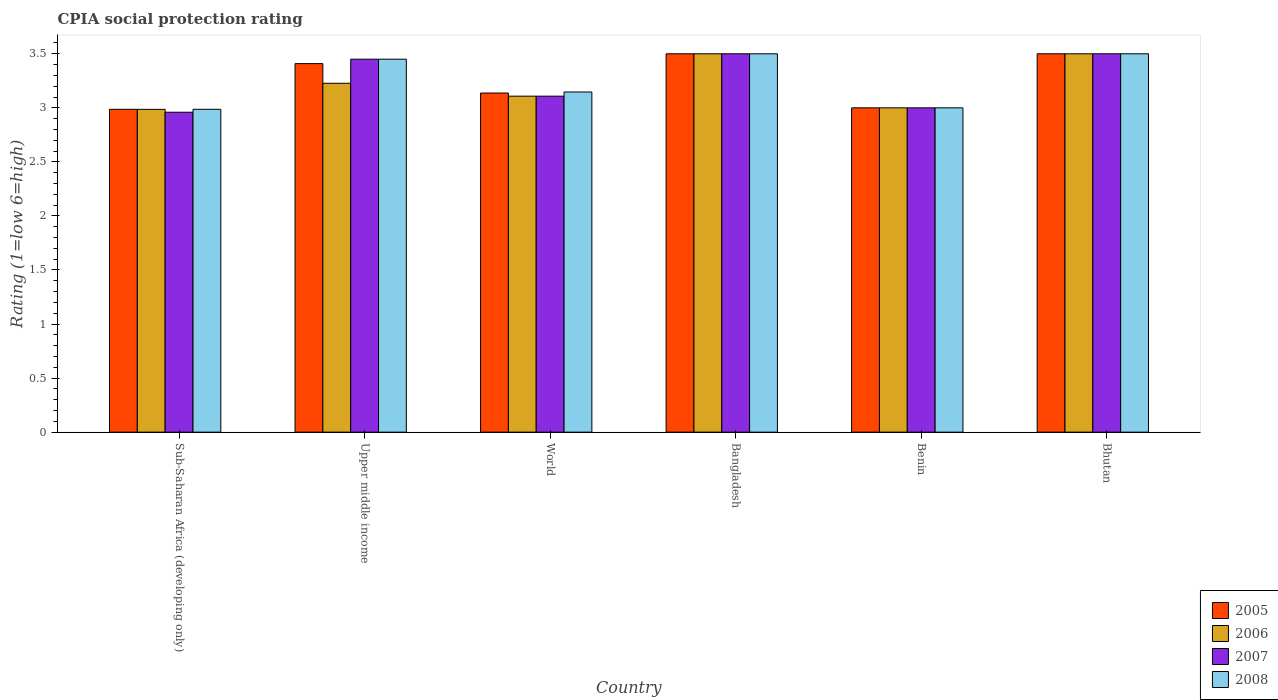Are the number of bars per tick equal to the number of legend labels?
Your answer should be very brief. Yes. Are the number of bars on each tick of the X-axis equal?
Ensure brevity in your answer.  Yes. How many bars are there on the 3rd tick from the right?
Ensure brevity in your answer.  4. What is the label of the 5th group of bars from the left?
Your response must be concise. Benin. In how many cases, is the number of bars for a given country not equal to the number of legend labels?
Your answer should be very brief. 0. What is the CPIA rating in 2008 in Bhutan?
Your answer should be compact. 3.5. Across all countries, what is the minimum CPIA rating in 2005?
Provide a succinct answer. 2.99. In which country was the CPIA rating in 2006 maximum?
Your response must be concise. Bangladesh. In which country was the CPIA rating in 2005 minimum?
Make the answer very short. Sub-Saharan Africa (developing only). What is the total CPIA rating in 2007 in the graph?
Keep it short and to the point. 19.52. What is the difference between the CPIA rating in 2007 in Benin and that in Sub-Saharan Africa (developing only)?
Provide a succinct answer. 0.04. What is the difference between the CPIA rating in 2005 in Bhutan and the CPIA rating in 2006 in Upper middle income?
Make the answer very short. 0.27. What is the average CPIA rating in 2006 per country?
Your response must be concise. 3.22. What is the difference between the CPIA rating of/in 2007 and CPIA rating of/in 2008 in Sub-Saharan Africa (developing only)?
Keep it short and to the point. -0.03. What is the ratio of the CPIA rating in 2006 in Bhutan to that in Upper middle income?
Your response must be concise. 1.08. Is the CPIA rating in 2005 in Bangladesh less than that in World?
Ensure brevity in your answer.  No. Is the difference between the CPIA rating in 2007 in Bangladesh and Sub-Saharan Africa (developing only) greater than the difference between the CPIA rating in 2008 in Bangladesh and Sub-Saharan Africa (developing only)?
Keep it short and to the point. Yes. What is the difference between the highest and the second highest CPIA rating in 2007?
Offer a terse response. -0.05. What is the difference between the highest and the lowest CPIA rating in 2007?
Provide a succinct answer. 0.54. In how many countries, is the CPIA rating in 2005 greater than the average CPIA rating in 2005 taken over all countries?
Offer a terse response. 3. Is the sum of the CPIA rating in 2006 in Bangladesh and Benin greater than the maximum CPIA rating in 2007 across all countries?
Make the answer very short. Yes. What does the 3rd bar from the left in World represents?
Your answer should be very brief. 2007. Is it the case that in every country, the sum of the CPIA rating in 2008 and CPIA rating in 2005 is greater than the CPIA rating in 2006?
Make the answer very short. Yes. What is the difference between two consecutive major ticks on the Y-axis?
Offer a very short reply. 0.5. Are the values on the major ticks of Y-axis written in scientific E-notation?
Make the answer very short. No. Where does the legend appear in the graph?
Offer a terse response. Bottom right. What is the title of the graph?
Make the answer very short. CPIA social protection rating. Does "2001" appear as one of the legend labels in the graph?
Your answer should be very brief. No. What is the label or title of the Y-axis?
Provide a short and direct response. Rating (1=low 6=high). What is the Rating (1=low 6=high) of 2005 in Sub-Saharan Africa (developing only)?
Give a very brief answer. 2.99. What is the Rating (1=low 6=high) of 2006 in Sub-Saharan Africa (developing only)?
Your answer should be compact. 2.99. What is the Rating (1=low 6=high) of 2007 in Sub-Saharan Africa (developing only)?
Your response must be concise. 2.96. What is the Rating (1=low 6=high) in 2008 in Sub-Saharan Africa (developing only)?
Give a very brief answer. 2.99. What is the Rating (1=low 6=high) of 2005 in Upper middle income?
Offer a very short reply. 3.41. What is the Rating (1=low 6=high) in 2006 in Upper middle income?
Your answer should be very brief. 3.23. What is the Rating (1=low 6=high) of 2007 in Upper middle income?
Keep it short and to the point. 3.45. What is the Rating (1=low 6=high) in 2008 in Upper middle income?
Your answer should be very brief. 3.45. What is the Rating (1=low 6=high) in 2005 in World?
Provide a succinct answer. 3.14. What is the Rating (1=low 6=high) in 2006 in World?
Your answer should be compact. 3.11. What is the Rating (1=low 6=high) of 2007 in World?
Keep it short and to the point. 3.11. What is the Rating (1=low 6=high) of 2008 in World?
Keep it short and to the point. 3.15. What is the Rating (1=low 6=high) of 2007 in Bangladesh?
Make the answer very short. 3.5. What is the Rating (1=low 6=high) of 2008 in Bangladesh?
Your answer should be very brief. 3.5. What is the Rating (1=low 6=high) of 2008 in Benin?
Your answer should be very brief. 3. What is the Rating (1=low 6=high) in 2006 in Bhutan?
Offer a very short reply. 3.5. What is the Rating (1=low 6=high) of 2008 in Bhutan?
Ensure brevity in your answer.  3.5. Across all countries, what is the maximum Rating (1=low 6=high) of 2005?
Your response must be concise. 3.5. Across all countries, what is the maximum Rating (1=low 6=high) of 2008?
Ensure brevity in your answer.  3.5. Across all countries, what is the minimum Rating (1=low 6=high) of 2005?
Keep it short and to the point. 2.99. Across all countries, what is the minimum Rating (1=low 6=high) of 2006?
Give a very brief answer. 2.99. Across all countries, what is the minimum Rating (1=low 6=high) in 2007?
Make the answer very short. 2.96. Across all countries, what is the minimum Rating (1=low 6=high) in 2008?
Provide a succinct answer. 2.99. What is the total Rating (1=low 6=high) in 2005 in the graph?
Offer a very short reply. 19.53. What is the total Rating (1=low 6=high) of 2006 in the graph?
Keep it short and to the point. 19.32. What is the total Rating (1=low 6=high) of 2007 in the graph?
Offer a terse response. 19.52. What is the total Rating (1=low 6=high) of 2008 in the graph?
Ensure brevity in your answer.  19.58. What is the difference between the Rating (1=low 6=high) in 2005 in Sub-Saharan Africa (developing only) and that in Upper middle income?
Provide a succinct answer. -0.42. What is the difference between the Rating (1=low 6=high) of 2006 in Sub-Saharan Africa (developing only) and that in Upper middle income?
Your response must be concise. -0.24. What is the difference between the Rating (1=low 6=high) of 2007 in Sub-Saharan Africa (developing only) and that in Upper middle income?
Your response must be concise. -0.49. What is the difference between the Rating (1=low 6=high) in 2008 in Sub-Saharan Africa (developing only) and that in Upper middle income?
Offer a very short reply. -0.46. What is the difference between the Rating (1=low 6=high) in 2005 in Sub-Saharan Africa (developing only) and that in World?
Give a very brief answer. -0.15. What is the difference between the Rating (1=low 6=high) in 2006 in Sub-Saharan Africa (developing only) and that in World?
Ensure brevity in your answer.  -0.12. What is the difference between the Rating (1=low 6=high) in 2007 in Sub-Saharan Africa (developing only) and that in World?
Provide a succinct answer. -0.15. What is the difference between the Rating (1=low 6=high) in 2008 in Sub-Saharan Africa (developing only) and that in World?
Make the answer very short. -0.16. What is the difference between the Rating (1=low 6=high) of 2005 in Sub-Saharan Africa (developing only) and that in Bangladesh?
Make the answer very short. -0.51. What is the difference between the Rating (1=low 6=high) in 2006 in Sub-Saharan Africa (developing only) and that in Bangladesh?
Offer a terse response. -0.51. What is the difference between the Rating (1=low 6=high) in 2007 in Sub-Saharan Africa (developing only) and that in Bangladesh?
Offer a very short reply. -0.54. What is the difference between the Rating (1=low 6=high) in 2008 in Sub-Saharan Africa (developing only) and that in Bangladesh?
Your response must be concise. -0.51. What is the difference between the Rating (1=low 6=high) of 2005 in Sub-Saharan Africa (developing only) and that in Benin?
Offer a very short reply. -0.01. What is the difference between the Rating (1=low 6=high) in 2006 in Sub-Saharan Africa (developing only) and that in Benin?
Make the answer very short. -0.01. What is the difference between the Rating (1=low 6=high) in 2007 in Sub-Saharan Africa (developing only) and that in Benin?
Provide a succinct answer. -0.04. What is the difference between the Rating (1=low 6=high) in 2008 in Sub-Saharan Africa (developing only) and that in Benin?
Offer a very short reply. -0.01. What is the difference between the Rating (1=low 6=high) in 2005 in Sub-Saharan Africa (developing only) and that in Bhutan?
Your response must be concise. -0.51. What is the difference between the Rating (1=low 6=high) in 2006 in Sub-Saharan Africa (developing only) and that in Bhutan?
Keep it short and to the point. -0.51. What is the difference between the Rating (1=low 6=high) of 2007 in Sub-Saharan Africa (developing only) and that in Bhutan?
Provide a succinct answer. -0.54. What is the difference between the Rating (1=low 6=high) of 2008 in Sub-Saharan Africa (developing only) and that in Bhutan?
Ensure brevity in your answer.  -0.51. What is the difference between the Rating (1=low 6=high) of 2005 in Upper middle income and that in World?
Keep it short and to the point. 0.27. What is the difference between the Rating (1=low 6=high) in 2006 in Upper middle income and that in World?
Provide a short and direct response. 0.12. What is the difference between the Rating (1=low 6=high) of 2007 in Upper middle income and that in World?
Provide a short and direct response. 0.34. What is the difference between the Rating (1=low 6=high) in 2008 in Upper middle income and that in World?
Your answer should be compact. 0.3. What is the difference between the Rating (1=low 6=high) in 2005 in Upper middle income and that in Bangladesh?
Give a very brief answer. -0.09. What is the difference between the Rating (1=low 6=high) of 2006 in Upper middle income and that in Bangladesh?
Your answer should be very brief. -0.27. What is the difference between the Rating (1=low 6=high) in 2007 in Upper middle income and that in Bangladesh?
Offer a very short reply. -0.05. What is the difference between the Rating (1=low 6=high) in 2008 in Upper middle income and that in Bangladesh?
Offer a terse response. -0.05. What is the difference between the Rating (1=low 6=high) of 2005 in Upper middle income and that in Benin?
Offer a very short reply. 0.41. What is the difference between the Rating (1=low 6=high) in 2006 in Upper middle income and that in Benin?
Offer a very short reply. 0.23. What is the difference between the Rating (1=low 6=high) in 2007 in Upper middle income and that in Benin?
Offer a very short reply. 0.45. What is the difference between the Rating (1=low 6=high) in 2008 in Upper middle income and that in Benin?
Offer a terse response. 0.45. What is the difference between the Rating (1=low 6=high) of 2005 in Upper middle income and that in Bhutan?
Ensure brevity in your answer.  -0.09. What is the difference between the Rating (1=low 6=high) of 2006 in Upper middle income and that in Bhutan?
Provide a short and direct response. -0.27. What is the difference between the Rating (1=low 6=high) of 2005 in World and that in Bangladesh?
Ensure brevity in your answer.  -0.36. What is the difference between the Rating (1=low 6=high) of 2006 in World and that in Bangladesh?
Give a very brief answer. -0.39. What is the difference between the Rating (1=low 6=high) of 2007 in World and that in Bangladesh?
Offer a very short reply. -0.39. What is the difference between the Rating (1=low 6=high) in 2008 in World and that in Bangladesh?
Your answer should be compact. -0.35. What is the difference between the Rating (1=low 6=high) of 2005 in World and that in Benin?
Provide a succinct answer. 0.14. What is the difference between the Rating (1=low 6=high) in 2006 in World and that in Benin?
Give a very brief answer. 0.11. What is the difference between the Rating (1=low 6=high) of 2007 in World and that in Benin?
Offer a terse response. 0.11. What is the difference between the Rating (1=low 6=high) of 2008 in World and that in Benin?
Offer a terse response. 0.15. What is the difference between the Rating (1=low 6=high) in 2005 in World and that in Bhutan?
Offer a terse response. -0.36. What is the difference between the Rating (1=low 6=high) in 2006 in World and that in Bhutan?
Your answer should be very brief. -0.39. What is the difference between the Rating (1=low 6=high) of 2007 in World and that in Bhutan?
Your answer should be compact. -0.39. What is the difference between the Rating (1=low 6=high) of 2008 in World and that in Bhutan?
Your response must be concise. -0.35. What is the difference between the Rating (1=low 6=high) in 2005 in Bangladesh and that in Benin?
Ensure brevity in your answer.  0.5. What is the difference between the Rating (1=low 6=high) of 2006 in Bangladesh and that in Benin?
Your response must be concise. 0.5. What is the difference between the Rating (1=low 6=high) in 2006 in Bangladesh and that in Bhutan?
Provide a succinct answer. 0. What is the difference between the Rating (1=low 6=high) of 2007 in Bangladesh and that in Bhutan?
Ensure brevity in your answer.  0. What is the difference between the Rating (1=low 6=high) in 2008 in Bangladesh and that in Bhutan?
Your response must be concise. 0. What is the difference between the Rating (1=low 6=high) in 2005 in Benin and that in Bhutan?
Your response must be concise. -0.5. What is the difference between the Rating (1=low 6=high) of 2007 in Benin and that in Bhutan?
Ensure brevity in your answer.  -0.5. What is the difference between the Rating (1=low 6=high) of 2008 in Benin and that in Bhutan?
Your response must be concise. -0.5. What is the difference between the Rating (1=low 6=high) of 2005 in Sub-Saharan Africa (developing only) and the Rating (1=low 6=high) of 2006 in Upper middle income?
Keep it short and to the point. -0.24. What is the difference between the Rating (1=low 6=high) of 2005 in Sub-Saharan Africa (developing only) and the Rating (1=low 6=high) of 2007 in Upper middle income?
Make the answer very short. -0.46. What is the difference between the Rating (1=low 6=high) in 2005 in Sub-Saharan Africa (developing only) and the Rating (1=low 6=high) in 2008 in Upper middle income?
Ensure brevity in your answer.  -0.46. What is the difference between the Rating (1=low 6=high) in 2006 in Sub-Saharan Africa (developing only) and the Rating (1=low 6=high) in 2007 in Upper middle income?
Your answer should be compact. -0.46. What is the difference between the Rating (1=low 6=high) of 2006 in Sub-Saharan Africa (developing only) and the Rating (1=low 6=high) of 2008 in Upper middle income?
Your answer should be very brief. -0.46. What is the difference between the Rating (1=low 6=high) in 2007 in Sub-Saharan Africa (developing only) and the Rating (1=low 6=high) in 2008 in Upper middle income?
Offer a terse response. -0.49. What is the difference between the Rating (1=low 6=high) in 2005 in Sub-Saharan Africa (developing only) and the Rating (1=low 6=high) in 2006 in World?
Your answer should be very brief. -0.12. What is the difference between the Rating (1=low 6=high) of 2005 in Sub-Saharan Africa (developing only) and the Rating (1=low 6=high) of 2007 in World?
Keep it short and to the point. -0.12. What is the difference between the Rating (1=low 6=high) in 2005 in Sub-Saharan Africa (developing only) and the Rating (1=low 6=high) in 2008 in World?
Provide a short and direct response. -0.16. What is the difference between the Rating (1=low 6=high) in 2006 in Sub-Saharan Africa (developing only) and the Rating (1=low 6=high) in 2007 in World?
Provide a succinct answer. -0.12. What is the difference between the Rating (1=low 6=high) in 2006 in Sub-Saharan Africa (developing only) and the Rating (1=low 6=high) in 2008 in World?
Make the answer very short. -0.16. What is the difference between the Rating (1=low 6=high) of 2007 in Sub-Saharan Africa (developing only) and the Rating (1=low 6=high) of 2008 in World?
Ensure brevity in your answer.  -0.19. What is the difference between the Rating (1=low 6=high) in 2005 in Sub-Saharan Africa (developing only) and the Rating (1=low 6=high) in 2006 in Bangladesh?
Offer a terse response. -0.51. What is the difference between the Rating (1=low 6=high) in 2005 in Sub-Saharan Africa (developing only) and the Rating (1=low 6=high) in 2007 in Bangladesh?
Ensure brevity in your answer.  -0.51. What is the difference between the Rating (1=low 6=high) in 2005 in Sub-Saharan Africa (developing only) and the Rating (1=low 6=high) in 2008 in Bangladesh?
Give a very brief answer. -0.51. What is the difference between the Rating (1=low 6=high) in 2006 in Sub-Saharan Africa (developing only) and the Rating (1=low 6=high) in 2007 in Bangladesh?
Keep it short and to the point. -0.51. What is the difference between the Rating (1=low 6=high) of 2006 in Sub-Saharan Africa (developing only) and the Rating (1=low 6=high) of 2008 in Bangladesh?
Provide a short and direct response. -0.51. What is the difference between the Rating (1=low 6=high) of 2007 in Sub-Saharan Africa (developing only) and the Rating (1=low 6=high) of 2008 in Bangladesh?
Keep it short and to the point. -0.54. What is the difference between the Rating (1=low 6=high) in 2005 in Sub-Saharan Africa (developing only) and the Rating (1=low 6=high) in 2006 in Benin?
Provide a short and direct response. -0.01. What is the difference between the Rating (1=low 6=high) in 2005 in Sub-Saharan Africa (developing only) and the Rating (1=low 6=high) in 2007 in Benin?
Give a very brief answer. -0.01. What is the difference between the Rating (1=low 6=high) of 2005 in Sub-Saharan Africa (developing only) and the Rating (1=low 6=high) of 2008 in Benin?
Offer a terse response. -0.01. What is the difference between the Rating (1=low 6=high) of 2006 in Sub-Saharan Africa (developing only) and the Rating (1=low 6=high) of 2007 in Benin?
Your response must be concise. -0.01. What is the difference between the Rating (1=low 6=high) in 2006 in Sub-Saharan Africa (developing only) and the Rating (1=low 6=high) in 2008 in Benin?
Ensure brevity in your answer.  -0.01. What is the difference between the Rating (1=low 6=high) of 2007 in Sub-Saharan Africa (developing only) and the Rating (1=low 6=high) of 2008 in Benin?
Offer a very short reply. -0.04. What is the difference between the Rating (1=low 6=high) in 2005 in Sub-Saharan Africa (developing only) and the Rating (1=low 6=high) in 2006 in Bhutan?
Provide a succinct answer. -0.51. What is the difference between the Rating (1=low 6=high) of 2005 in Sub-Saharan Africa (developing only) and the Rating (1=low 6=high) of 2007 in Bhutan?
Your answer should be very brief. -0.51. What is the difference between the Rating (1=low 6=high) in 2005 in Sub-Saharan Africa (developing only) and the Rating (1=low 6=high) in 2008 in Bhutan?
Offer a very short reply. -0.51. What is the difference between the Rating (1=low 6=high) of 2006 in Sub-Saharan Africa (developing only) and the Rating (1=low 6=high) of 2007 in Bhutan?
Offer a terse response. -0.51. What is the difference between the Rating (1=low 6=high) of 2006 in Sub-Saharan Africa (developing only) and the Rating (1=low 6=high) of 2008 in Bhutan?
Ensure brevity in your answer.  -0.51. What is the difference between the Rating (1=low 6=high) of 2007 in Sub-Saharan Africa (developing only) and the Rating (1=low 6=high) of 2008 in Bhutan?
Offer a very short reply. -0.54. What is the difference between the Rating (1=low 6=high) of 2005 in Upper middle income and the Rating (1=low 6=high) of 2006 in World?
Keep it short and to the point. 0.3. What is the difference between the Rating (1=low 6=high) of 2005 in Upper middle income and the Rating (1=low 6=high) of 2007 in World?
Keep it short and to the point. 0.3. What is the difference between the Rating (1=low 6=high) of 2005 in Upper middle income and the Rating (1=low 6=high) of 2008 in World?
Offer a very short reply. 0.26. What is the difference between the Rating (1=low 6=high) of 2006 in Upper middle income and the Rating (1=low 6=high) of 2007 in World?
Ensure brevity in your answer.  0.12. What is the difference between the Rating (1=low 6=high) in 2006 in Upper middle income and the Rating (1=low 6=high) in 2008 in World?
Your answer should be very brief. 0.08. What is the difference between the Rating (1=low 6=high) of 2007 in Upper middle income and the Rating (1=low 6=high) of 2008 in World?
Give a very brief answer. 0.3. What is the difference between the Rating (1=low 6=high) of 2005 in Upper middle income and the Rating (1=low 6=high) of 2006 in Bangladesh?
Provide a succinct answer. -0.09. What is the difference between the Rating (1=low 6=high) in 2005 in Upper middle income and the Rating (1=low 6=high) in 2007 in Bangladesh?
Your response must be concise. -0.09. What is the difference between the Rating (1=low 6=high) of 2005 in Upper middle income and the Rating (1=low 6=high) of 2008 in Bangladesh?
Offer a very short reply. -0.09. What is the difference between the Rating (1=low 6=high) of 2006 in Upper middle income and the Rating (1=low 6=high) of 2007 in Bangladesh?
Your answer should be compact. -0.27. What is the difference between the Rating (1=low 6=high) in 2006 in Upper middle income and the Rating (1=low 6=high) in 2008 in Bangladesh?
Provide a short and direct response. -0.27. What is the difference between the Rating (1=low 6=high) of 2007 in Upper middle income and the Rating (1=low 6=high) of 2008 in Bangladesh?
Give a very brief answer. -0.05. What is the difference between the Rating (1=low 6=high) in 2005 in Upper middle income and the Rating (1=low 6=high) in 2006 in Benin?
Your answer should be compact. 0.41. What is the difference between the Rating (1=low 6=high) of 2005 in Upper middle income and the Rating (1=low 6=high) of 2007 in Benin?
Provide a succinct answer. 0.41. What is the difference between the Rating (1=low 6=high) of 2005 in Upper middle income and the Rating (1=low 6=high) of 2008 in Benin?
Keep it short and to the point. 0.41. What is the difference between the Rating (1=low 6=high) of 2006 in Upper middle income and the Rating (1=low 6=high) of 2007 in Benin?
Offer a very short reply. 0.23. What is the difference between the Rating (1=low 6=high) of 2006 in Upper middle income and the Rating (1=low 6=high) of 2008 in Benin?
Keep it short and to the point. 0.23. What is the difference between the Rating (1=low 6=high) of 2007 in Upper middle income and the Rating (1=low 6=high) of 2008 in Benin?
Keep it short and to the point. 0.45. What is the difference between the Rating (1=low 6=high) of 2005 in Upper middle income and the Rating (1=low 6=high) of 2006 in Bhutan?
Make the answer very short. -0.09. What is the difference between the Rating (1=low 6=high) of 2005 in Upper middle income and the Rating (1=low 6=high) of 2007 in Bhutan?
Give a very brief answer. -0.09. What is the difference between the Rating (1=low 6=high) of 2005 in Upper middle income and the Rating (1=low 6=high) of 2008 in Bhutan?
Offer a very short reply. -0.09. What is the difference between the Rating (1=low 6=high) in 2006 in Upper middle income and the Rating (1=low 6=high) in 2007 in Bhutan?
Your answer should be very brief. -0.27. What is the difference between the Rating (1=low 6=high) in 2006 in Upper middle income and the Rating (1=low 6=high) in 2008 in Bhutan?
Offer a very short reply. -0.27. What is the difference between the Rating (1=low 6=high) of 2007 in Upper middle income and the Rating (1=low 6=high) of 2008 in Bhutan?
Offer a terse response. -0.05. What is the difference between the Rating (1=low 6=high) in 2005 in World and the Rating (1=low 6=high) in 2006 in Bangladesh?
Your answer should be very brief. -0.36. What is the difference between the Rating (1=low 6=high) in 2005 in World and the Rating (1=low 6=high) in 2007 in Bangladesh?
Keep it short and to the point. -0.36. What is the difference between the Rating (1=low 6=high) in 2005 in World and the Rating (1=low 6=high) in 2008 in Bangladesh?
Ensure brevity in your answer.  -0.36. What is the difference between the Rating (1=low 6=high) of 2006 in World and the Rating (1=low 6=high) of 2007 in Bangladesh?
Make the answer very short. -0.39. What is the difference between the Rating (1=low 6=high) of 2006 in World and the Rating (1=low 6=high) of 2008 in Bangladesh?
Provide a succinct answer. -0.39. What is the difference between the Rating (1=low 6=high) of 2007 in World and the Rating (1=low 6=high) of 2008 in Bangladesh?
Keep it short and to the point. -0.39. What is the difference between the Rating (1=low 6=high) in 2005 in World and the Rating (1=low 6=high) in 2006 in Benin?
Provide a succinct answer. 0.14. What is the difference between the Rating (1=low 6=high) of 2005 in World and the Rating (1=low 6=high) of 2007 in Benin?
Offer a very short reply. 0.14. What is the difference between the Rating (1=low 6=high) of 2005 in World and the Rating (1=low 6=high) of 2008 in Benin?
Ensure brevity in your answer.  0.14. What is the difference between the Rating (1=low 6=high) of 2006 in World and the Rating (1=low 6=high) of 2007 in Benin?
Provide a succinct answer. 0.11. What is the difference between the Rating (1=low 6=high) of 2006 in World and the Rating (1=low 6=high) of 2008 in Benin?
Ensure brevity in your answer.  0.11. What is the difference between the Rating (1=low 6=high) in 2007 in World and the Rating (1=low 6=high) in 2008 in Benin?
Your answer should be very brief. 0.11. What is the difference between the Rating (1=low 6=high) of 2005 in World and the Rating (1=low 6=high) of 2006 in Bhutan?
Give a very brief answer. -0.36. What is the difference between the Rating (1=low 6=high) in 2005 in World and the Rating (1=low 6=high) in 2007 in Bhutan?
Offer a very short reply. -0.36. What is the difference between the Rating (1=low 6=high) of 2005 in World and the Rating (1=low 6=high) of 2008 in Bhutan?
Provide a succinct answer. -0.36. What is the difference between the Rating (1=low 6=high) of 2006 in World and the Rating (1=low 6=high) of 2007 in Bhutan?
Provide a succinct answer. -0.39. What is the difference between the Rating (1=low 6=high) of 2006 in World and the Rating (1=low 6=high) of 2008 in Bhutan?
Offer a very short reply. -0.39. What is the difference between the Rating (1=low 6=high) in 2007 in World and the Rating (1=low 6=high) in 2008 in Bhutan?
Your response must be concise. -0.39. What is the difference between the Rating (1=low 6=high) in 2006 in Bangladesh and the Rating (1=low 6=high) in 2007 in Benin?
Your answer should be compact. 0.5. What is the difference between the Rating (1=low 6=high) of 2006 in Bangladesh and the Rating (1=low 6=high) of 2008 in Benin?
Provide a succinct answer. 0.5. What is the difference between the Rating (1=low 6=high) of 2005 in Bangladesh and the Rating (1=low 6=high) of 2006 in Bhutan?
Give a very brief answer. 0. What is the difference between the Rating (1=low 6=high) in 2005 in Bangladesh and the Rating (1=low 6=high) in 2007 in Bhutan?
Keep it short and to the point. 0. What is the difference between the Rating (1=low 6=high) of 2005 in Bangladesh and the Rating (1=low 6=high) of 2008 in Bhutan?
Give a very brief answer. 0. What is the difference between the Rating (1=low 6=high) in 2006 in Bangladesh and the Rating (1=low 6=high) in 2008 in Bhutan?
Provide a short and direct response. 0. What is the difference between the Rating (1=low 6=high) of 2007 in Bangladesh and the Rating (1=low 6=high) of 2008 in Bhutan?
Your response must be concise. 0. What is the difference between the Rating (1=low 6=high) of 2005 in Benin and the Rating (1=low 6=high) of 2007 in Bhutan?
Offer a very short reply. -0.5. What is the difference between the Rating (1=low 6=high) of 2005 in Benin and the Rating (1=low 6=high) of 2008 in Bhutan?
Give a very brief answer. -0.5. What is the difference between the Rating (1=low 6=high) in 2006 in Benin and the Rating (1=low 6=high) in 2007 in Bhutan?
Your answer should be compact. -0.5. What is the difference between the Rating (1=low 6=high) in 2007 in Benin and the Rating (1=low 6=high) in 2008 in Bhutan?
Your answer should be very brief. -0.5. What is the average Rating (1=low 6=high) in 2005 per country?
Your answer should be compact. 3.26. What is the average Rating (1=low 6=high) in 2006 per country?
Make the answer very short. 3.22. What is the average Rating (1=low 6=high) in 2007 per country?
Ensure brevity in your answer.  3.25. What is the average Rating (1=low 6=high) in 2008 per country?
Your response must be concise. 3.26. What is the difference between the Rating (1=low 6=high) of 2005 and Rating (1=low 6=high) of 2007 in Sub-Saharan Africa (developing only)?
Offer a very short reply. 0.03. What is the difference between the Rating (1=low 6=high) in 2006 and Rating (1=low 6=high) in 2007 in Sub-Saharan Africa (developing only)?
Keep it short and to the point. 0.03. What is the difference between the Rating (1=low 6=high) of 2006 and Rating (1=low 6=high) of 2008 in Sub-Saharan Africa (developing only)?
Keep it short and to the point. -0. What is the difference between the Rating (1=low 6=high) of 2007 and Rating (1=low 6=high) of 2008 in Sub-Saharan Africa (developing only)?
Provide a succinct answer. -0.03. What is the difference between the Rating (1=low 6=high) in 2005 and Rating (1=low 6=high) in 2006 in Upper middle income?
Your answer should be compact. 0.18. What is the difference between the Rating (1=low 6=high) in 2005 and Rating (1=low 6=high) in 2007 in Upper middle income?
Provide a short and direct response. -0.04. What is the difference between the Rating (1=low 6=high) in 2005 and Rating (1=low 6=high) in 2008 in Upper middle income?
Ensure brevity in your answer.  -0.04. What is the difference between the Rating (1=low 6=high) in 2006 and Rating (1=low 6=high) in 2007 in Upper middle income?
Offer a terse response. -0.22. What is the difference between the Rating (1=low 6=high) in 2006 and Rating (1=low 6=high) in 2008 in Upper middle income?
Keep it short and to the point. -0.22. What is the difference between the Rating (1=low 6=high) in 2005 and Rating (1=low 6=high) in 2006 in World?
Your answer should be very brief. 0.03. What is the difference between the Rating (1=low 6=high) of 2005 and Rating (1=low 6=high) of 2007 in World?
Make the answer very short. 0.03. What is the difference between the Rating (1=low 6=high) of 2005 and Rating (1=low 6=high) of 2008 in World?
Offer a terse response. -0.01. What is the difference between the Rating (1=low 6=high) in 2006 and Rating (1=low 6=high) in 2008 in World?
Keep it short and to the point. -0.04. What is the difference between the Rating (1=low 6=high) in 2007 and Rating (1=low 6=high) in 2008 in World?
Give a very brief answer. -0.04. What is the difference between the Rating (1=low 6=high) in 2005 and Rating (1=low 6=high) in 2007 in Bangladesh?
Your answer should be compact. 0. What is the difference between the Rating (1=low 6=high) in 2006 and Rating (1=low 6=high) in 2008 in Bangladesh?
Make the answer very short. 0. What is the difference between the Rating (1=low 6=high) in 2007 and Rating (1=low 6=high) in 2008 in Bangladesh?
Your answer should be compact. 0. What is the difference between the Rating (1=low 6=high) in 2006 and Rating (1=low 6=high) in 2008 in Benin?
Your answer should be compact. 0. What is the difference between the Rating (1=low 6=high) of 2007 and Rating (1=low 6=high) of 2008 in Benin?
Make the answer very short. 0. What is the difference between the Rating (1=low 6=high) in 2006 and Rating (1=low 6=high) in 2007 in Bhutan?
Provide a short and direct response. 0. What is the difference between the Rating (1=low 6=high) in 2007 and Rating (1=low 6=high) in 2008 in Bhutan?
Your answer should be very brief. 0. What is the ratio of the Rating (1=low 6=high) of 2005 in Sub-Saharan Africa (developing only) to that in Upper middle income?
Offer a terse response. 0.88. What is the ratio of the Rating (1=low 6=high) in 2006 in Sub-Saharan Africa (developing only) to that in Upper middle income?
Offer a terse response. 0.93. What is the ratio of the Rating (1=low 6=high) in 2007 in Sub-Saharan Africa (developing only) to that in Upper middle income?
Provide a short and direct response. 0.86. What is the ratio of the Rating (1=low 6=high) of 2008 in Sub-Saharan Africa (developing only) to that in Upper middle income?
Your answer should be very brief. 0.87. What is the ratio of the Rating (1=low 6=high) in 2006 in Sub-Saharan Africa (developing only) to that in World?
Give a very brief answer. 0.96. What is the ratio of the Rating (1=low 6=high) in 2007 in Sub-Saharan Africa (developing only) to that in World?
Offer a terse response. 0.95. What is the ratio of the Rating (1=low 6=high) of 2008 in Sub-Saharan Africa (developing only) to that in World?
Provide a succinct answer. 0.95. What is the ratio of the Rating (1=low 6=high) in 2005 in Sub-Saharan Africa (developing only) to that in Bangladesh?
Your answer should be compact. 0.85. What is the ratio of the Rating (1=low 6=high) in 2006 in Sub-Saharan Africa (developing only) to that in Bangladesh?
Your response must be concise. 0.85. What is the ratio of the Rating (1=low 6=high) of 2007 in Sub-Saharan Africa (developing only) to that in Bangladesh?
Your response must be concise. 0.85. What is the ratio of the Rating (1=low 6=high) of 2008 in Sub-Saharan Africa (developing only) to that in Bangladesh?
Your response must be concise. 0.85. What is the ratio of the Rating (1=low 6=high) of 2005 in Sub-Saharan Africa (developing only) to that in Benin?
Offer a very short reply. 1. What is the ratio of the Rating (1=low 6=high) in 2006 in Sub-Saharan Africa (developing only) to that in Benin?
Provide a short and direct response. 1. What is the ratio of the Rating (1=low 6=high) of 2007 in Sub-Saharan Africa (developing only) to that in Benin?
Provide a short and direct response. 0.99. What is the ratio of the Rating (1=low 6=high) in 2008 in Sub-Saharan Africa (developing only) to that in Benin?
Your response must be concise. 1. What is the ratio of the Rating (1=low 6=high) of 2005 in Sub-Saharan Africa (developing only) to that in Bhutan?
Ensure brevity in your answer.  0.85. What is the ratio of the Rating (1=low 6=high) of 2006 in Sub-Saharan Africa (developing only) to that in Bhutan?
Give a very brief answer. 0.85. What is the ratio of the Rating (1=low 6=high) in 2007 in Sub-Saharan Africa (developing only) to that in Bhutan?
Provide a short and direct response. 0.85. What is the ratio of the Rating (1=low 6=high) of 2008 in Sub-Saharan Africa (developing only) to that in Bhutan?
Your answer should be very brief. 0.85. What is the ratio of the Rating (1=low 6=high) of 2005 in Upper middle income to that in World?
Offer a terse response. 1.09. What is the ratio of the Rating (1=low 6=high) of 2006 in Upper middle income to that in World?
Provide a succinct answer. 1.04. What is the ratio of the Rating (1=low 6=high) in 2007 in Upper middle income to that in World?
Ensure brevity in your answer.  1.11. What is the ratio of the Rating (1=low 6=high) in 2008 in Upper middle income to that in World?
Your response must be concise. 1.1. What is the ratio of the Rating (1=low 6=high) in 2006 in Upper middle income to that in Bangladesh?
Provide a succinct answer. 0.92. What is the ratio of the Rating (1=low 6=high) in 2007 in Upper middle income to that in Bangladesh?
Provide a succinct answer. 0.99. What is the ratio of the Rating (1=low 6=high) of 2008 in Upper middle income to that in Bangladesh?
Offer a very short reply. 0.99. What is the ratio of the Rating (1=low 6=high) of 2005 in Upper middle income to that in Benin?
Provide a short and direct response. 1.14. What is the ratio of the Rating (1=low 6=high) of 2006 in Upper middle income to that in Benin?
Offer a terse response. 1.08. What is the ratio of the Rating (1=low 6=high) in 2007 in Upper middle income to that in Benin?
Provide a succinct answer. 1.15. What is the ratio of the Rating (1=low 6=high) of 2008 in Upper middle income to that in Benin?
Your response must be concise. 1.15. What is the ratio of the Rating (1=low 6=high) in 2005 in Upper middle income to that in Bhutan?
Make the answer very short. 0.97. What is the ratio of the Rating (1=low 6=high) in 2006 in Upper middle income to that in Bhutan?
Provide a short and direct response. 0.92. What is the ratio of the Rating (1=low 6=high) of 2007 in Upper middle income to that in Bhutan?
Your answer should be compact. 0.99. What is the ratio of the Rating (1=low 6=high) of 2008 in Upper middle income to that in Bhutan?
Your response must be concise. 0.99. What is the ratio of the Rating (1=low 6=high) in 2005 in World to that in Bangladesh?
Offer a very short reply. 0.9. What is the ratio of the Rating (1=low 6=high) in 2006 in World to that in Bangladesh?
Provide a succinct answer. 0.89. What is the ratio of the Rating (1=low 6=high) in 2007 in World to that in Bangladesh?
Provide a succinct answer. 0.89. What is the ratio of the Rating (1=low 6=high) of 2008 in World to that in Bangladesh?
Ensure brevity in your answer.  0.9. What is the ratio of the Rating (1=low 6=high) in 2005 in World to that in Benin?
Offer a terse response. 1.05. What is the ratio of the Rating (1=low 6=high) of 2006 in World to that in Benin?
Offer a very short reply. 1.04. What is the ratio of the Rating (1=low 6=high) of 2007 in World to that in Benin?
Your answer should be compact. 1.04. What is the ratio of the Rating (1=low 6=high) of 2008 in World to that in Benin?
Your answer should be very brief. 1.05. What is the ratio of the Rating (1=low 6=high) in 2005 in World to that in Bhutan?
Your answer should be compact. 0.9. What is the ratio of the Rating (1=low 6=high) in 2006 in World to that in Bhutan?
Ensure brevity in your answer.  0.89. What is the ratio of the Rating (1=low 6=high) of 2007 in World to that in Bhutan?
Give a very brief answer. 0.89. What is the ratio of the Rating (1=low 6=high) in 2008 in World to that in Bhutan?
Make the answer very short. 0.9. What is the ratio of the Rating (1=low 6=high) of 2005 in Bangladesh to that in Benin?
Offer a terse response. 1.17. What is the ratio of the Rating (1=low 6=high) of 2007 in Bangladesh to that in Benin?
Ensure brevity in your answer.  1.17. What is the ratio of the Rating (1=low 6=high) of 2005 in Bangladesh to that in Bhutan?
Make the answer very short. 1. What is the ratio of the Rating (1=low 6=high) in 2007 in Bangladesh to that in Bhutan?
Give a very brief answer. 1. What is the ratio of the Rating (1=low 6=high) of 2006 in Benin to that in Bhutan?
Provide a succinct answer. 0.86. What is the ratio of the Rating (1=low 6=high) in 2007 in Benin to that in Bhutan?
Keep it short and to the point. 0.86. What is the ratio of the Rating (1=low 6=high) of 2008 in Benin to that in Bhutan?
Offer a very short reply. 0.86. What is the difference between the highest and the second highest Rating (1=low 6=high) in 2005?
Ensure brevity in your answer.  0. What is the difference between the highest and the second highest Rating (1=low 6=high) in 2006?
Offer a terse response. 0. What is the difference between the highest and the second highest Rating (1=low 6=high) in 2007?
Provide a short and direct response. 0. What is the difference between the highest and the lowest Rating (1=low 6=high) of 2005?
Your response must be concise. 0.51. What is the difference between the highest and the lowest Rating (1=low 6=high) in 2006?
Your answer should be very brief. 0.51. What is the difference between the highest and the lowest Rating (1=low 6=high) of 2007?
Provide a short and direct response. 0.54. What is the difference between the highest and the lowest Rating (1=low 6=high) in 2008?
Keep it short and to the point. 0.51. 